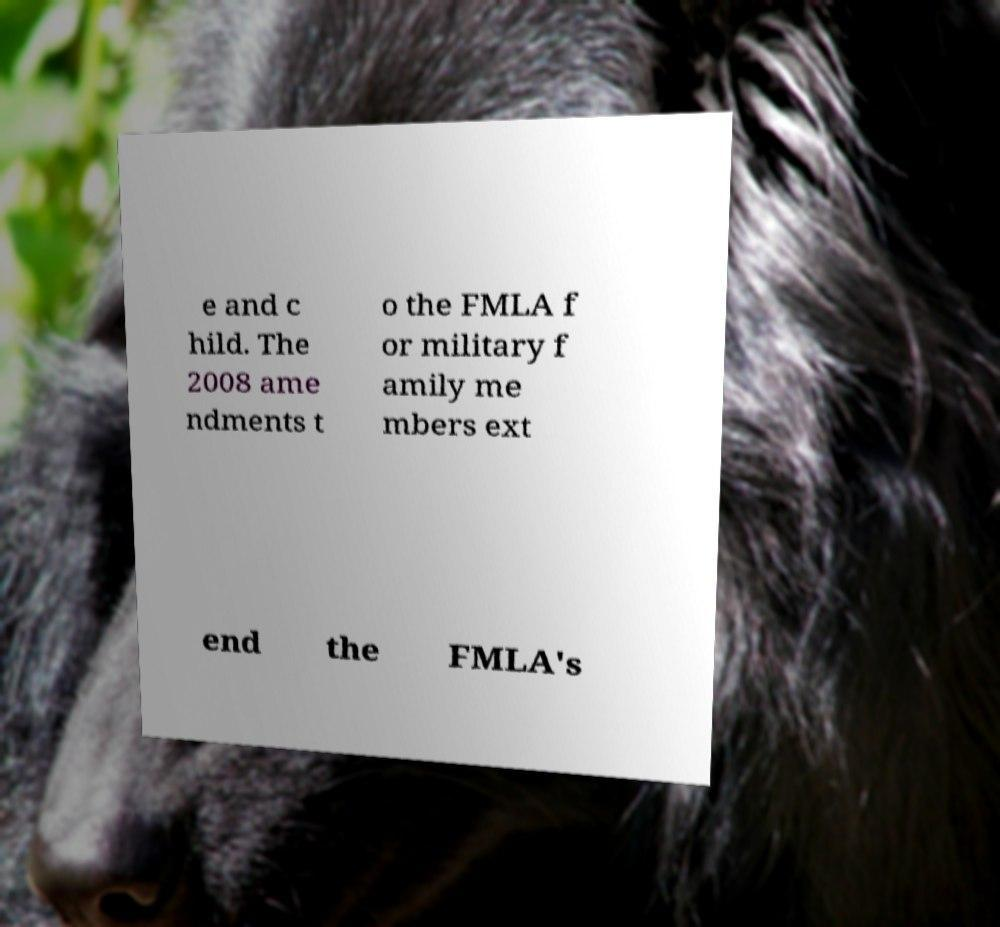Please identify and transcribe the text found in this image. e and c hild. The 2008 ame ndments t o the FMLA f or military f amily me mbers ext end the FMLA's 